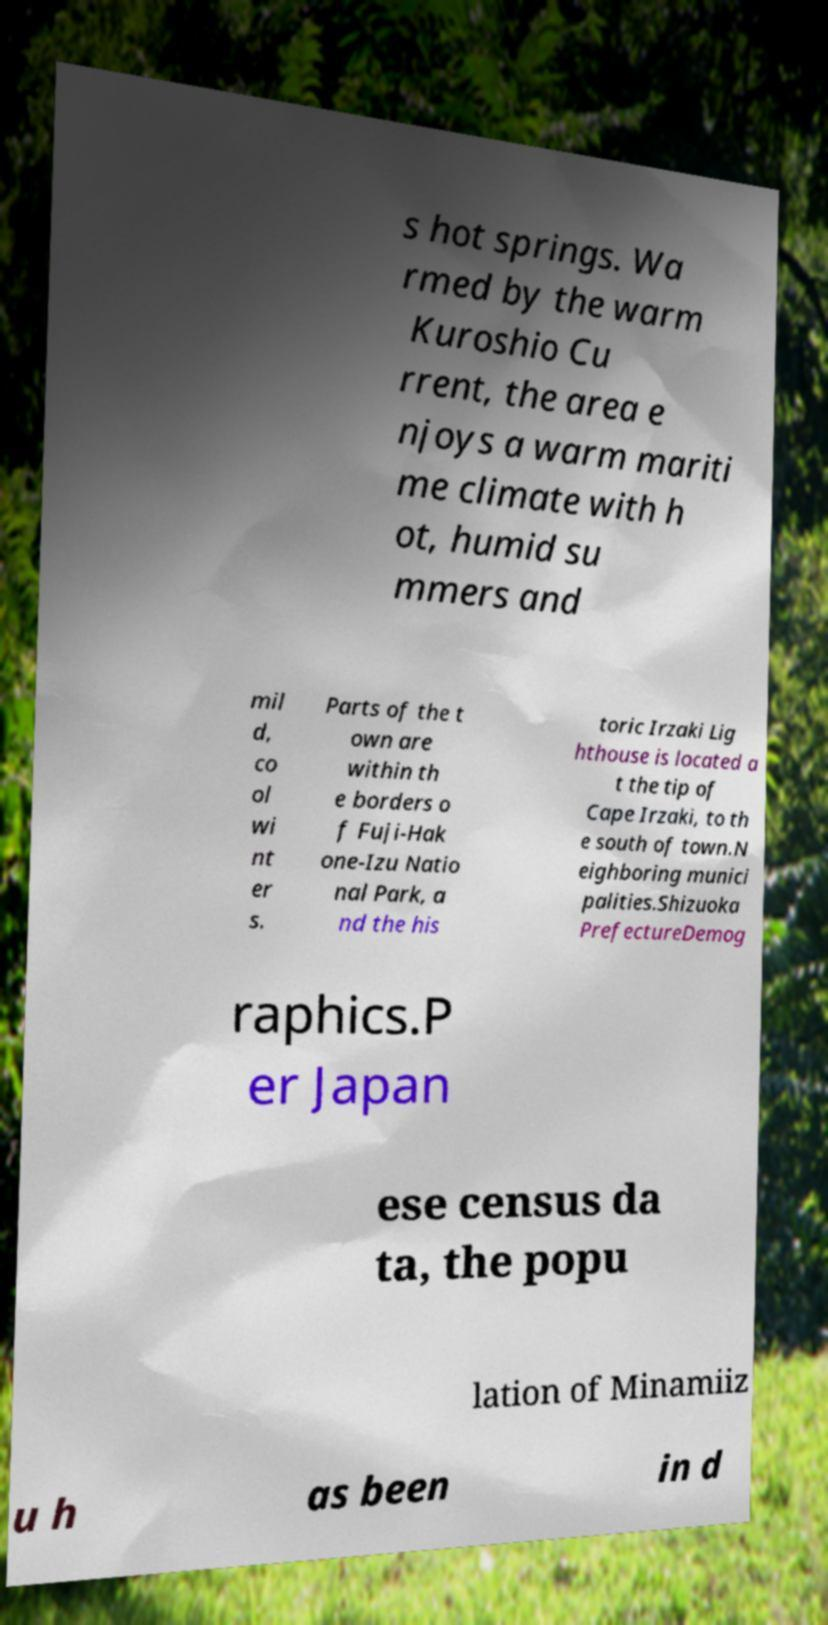Could you assist in decoding the text presented in this image and type it out clearly? s hot springs. Wa rmed by the warm Kuroshio Cu rrent, the area e njoys a warm mariti me climate with h ot, humid su mmers and mil d, co ol wi nt er s. Parts of the t own are within th e borders o f Fuji-Hak one-Izu Natio nal Park, a nd the his toric Irzaki Lig hthouse is located a t the tip of Cape Irzaki, to th e south of town.N eighboring munici palities.Shizuoka PrefectureDemog raphics.P er Japan ese census da ta, the popu lation of Minamiiz u h as been in d 